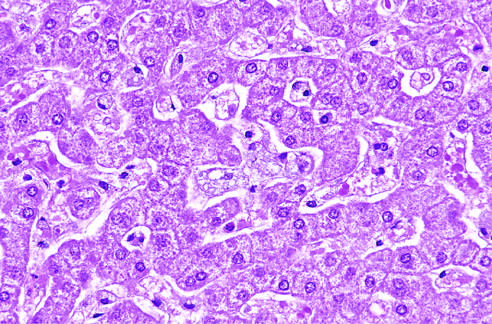do the hepatocytes and kupffer cells have a foamy, vacuolated appearance resulting from deposition of lipids?
Answer the question using a single word or phrase. Yes 